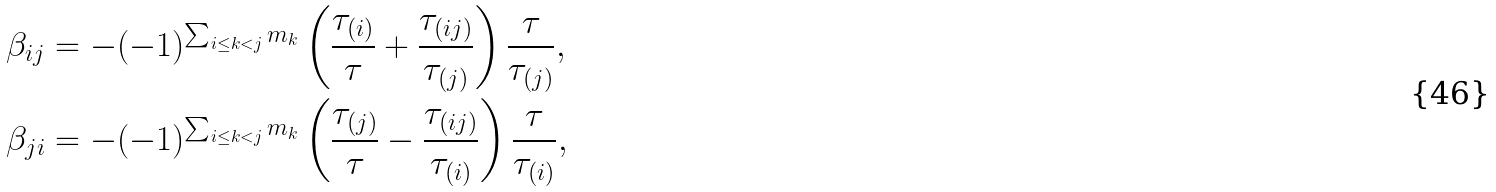Convert formula to latex. <formula><loc_0><loc_0><loc_500><loc_500>\beta _ { i j } & = - ( - 1 ) ^ { \sum _ { i \leq k < j } m _ { k } } \left ( \frac { \tau _ { ( i ) } } { \tau } + \frac { \tau _ { ( i j ) } } { \tau _ { ( j ) } } \right ) \frac { \tau } { \tau _ { ( j ) } } , \\ \beta _ { j i } & = - ( - 1 ) ^ { \sum _ { i \leq k < j } m _ { k } } \left ( \frac { \tau _ { ( j ) } } { \tau } - \frac { \tau _ { ( i j ) } } { \tau _ { ( i ) } } \right ) \frac { \tau } { \tau _ { ( i ) } } ,</formula> 